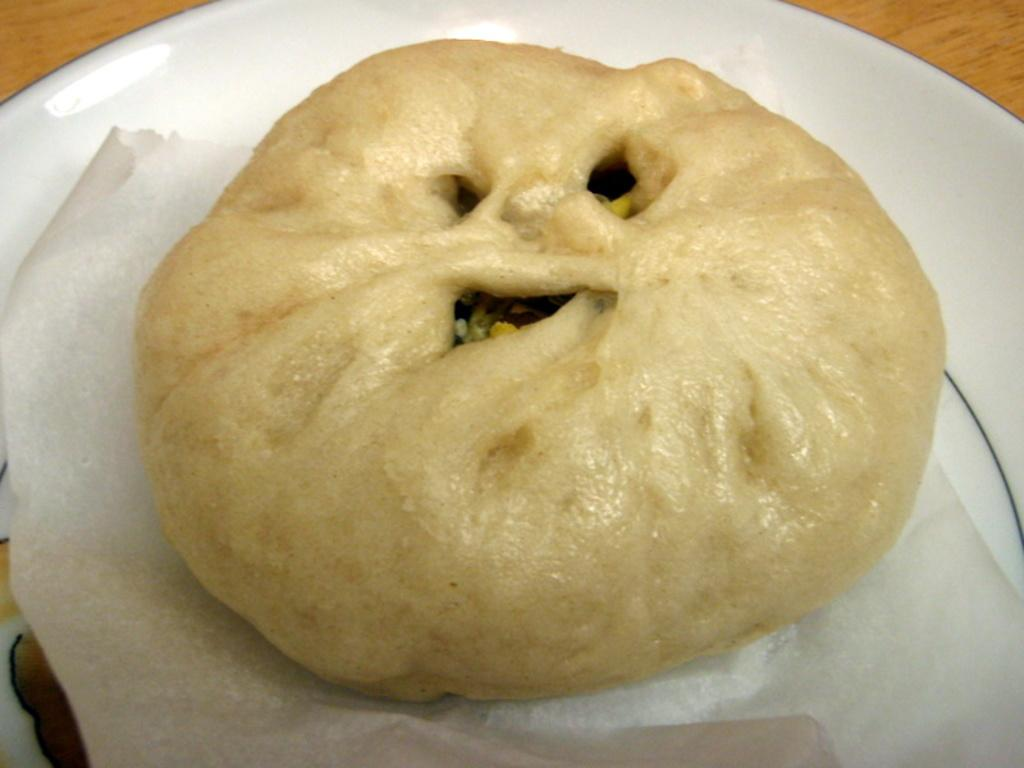What is on the plate that is visible in the image? The plate contains food items. Where is the plate located in the image? The plate is placed on a table. What type of ground can be seen beneath the plate in the image? There is no ground visible beneath the plate in the image; it is placed on a table. 